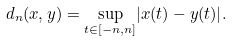<formula> <loc_0><loc_0><loc_500><loc_500>d _ { n } ( x , y ) = \underset { t \in [ - n , n ] } \sup { | x ( t ) - y ( t ) | } .</formula> 